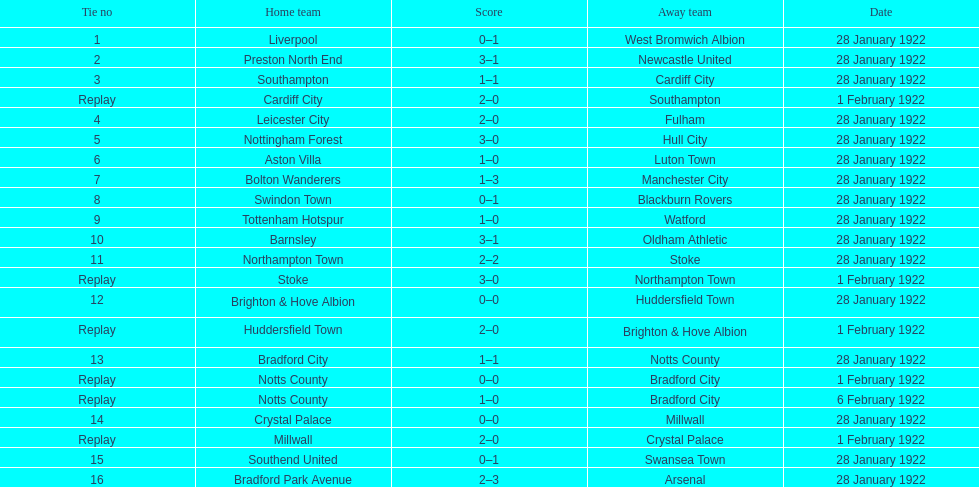Which home team is recorded as having a 3-1 score first? Preston North End. 